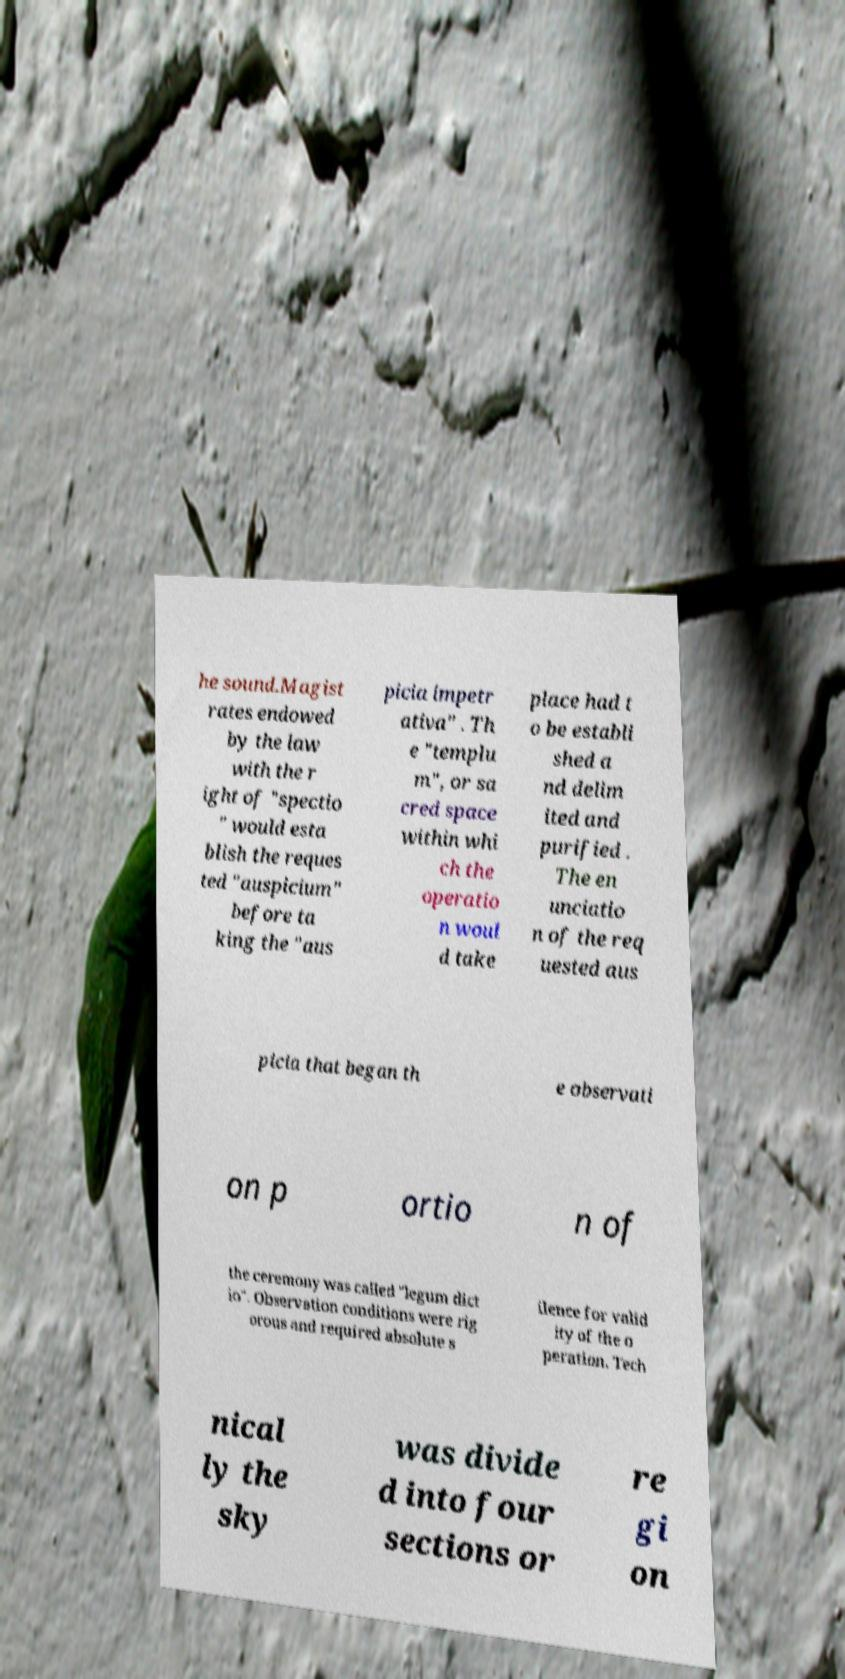For documentation purposes, I need the text within this image transcribed. Could you provide that? he sound.Magist rates endowed by the law with the r ight of "spectio " would esta blish the reques ted "auspicium" before ta king the "aus picia impetr ativa" . Th e "templu m", or sa cred space within whi ch the operatio n woul d take place had t o be establi shed a nd delim ited and purified . The en unciatio n of the req uested aus picia that began th e observati on p ortio n of the ceremony was called "legum dict io". Observation conditions were rig orous and required absolute s ilence for valid ity of the o peration. Tech nical ly the sky was divide d into four sections or re gi on 